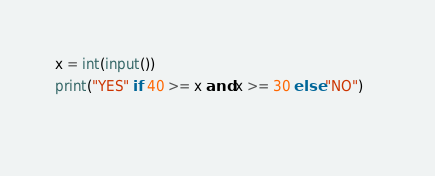Convert code to text. <code><loc_0><loc_0><loc_500><loc_500><_Python_>x = int(input())
print("YES" if 40 >= x and x >= 30 else "NO")    
   </code> 